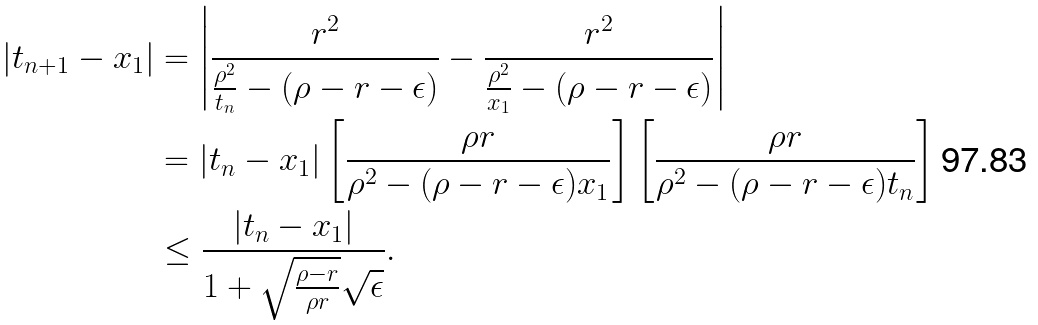Convert formula to latex. <formula><loc_0><loc_0><loc_500><loc_500>| t _ { n + 1 } - x _ { 1 } | & = \left | \frac { r ^ { 2 } } { \frac { \rho ^ { 2 } } { t _ { n } } - ( \rho - r - \epsilon ) } - \frac { r ^ { 2 } } { \frac { \rho ^ { 2 } } { x _ { 1 } } - ( \rho - r - \epsilon ) } \right | \\ & = | t _ { n } - x _ { 1 } | \left [ \frac { \rho r } { \rho ^ { 2 } - ( \rho - r - \epsilon ) x _ { 1 } } \right ] \left [ \frac { \rho r } { \rho ^ { 2 } - ( \rho - r - \epsilon ) t _ { n } } \right ] \\ & \leq \frac { | t _ { n } - x _ { 1 } | } { 1 + \sqrt { \frac { \rho - r } { \rho r } } \sqrt { \epsilon } } .</formula> 